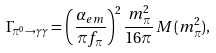Convert formula to latex. <formula><loc_0><loc_0><loc_500><loc_500>\Gamma _ { \pi ^ { 0 } \rightarrow \gamma \gamma } = \left ( \frac { \alpha _ { e m } } { \pi f _ { \pi } } \right ) ^ { 2 } \frac { m _ { \pi } ^ { 2 } } { 1 6 \pi } \, M ( m _ { \pi } ^ { 2 } ) ,</formula> 